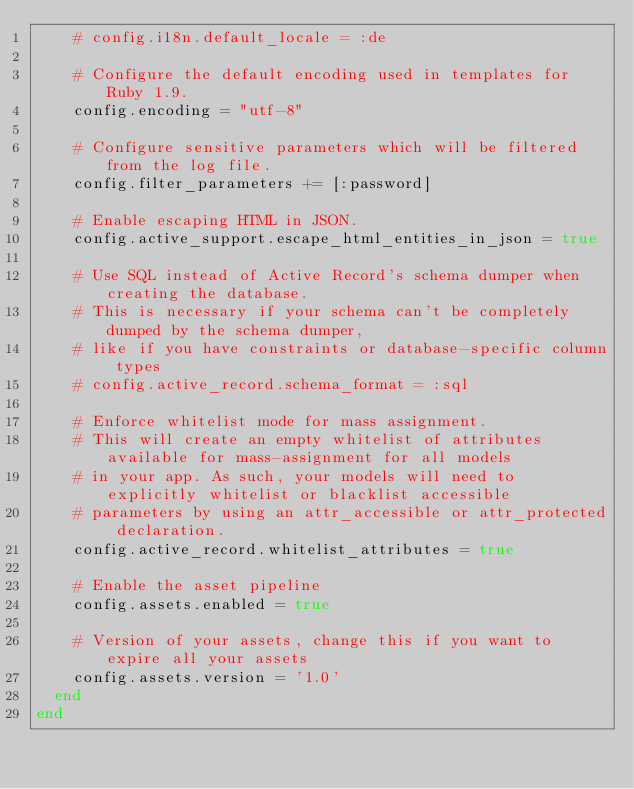Convert code to text. <code><loc_0><loc_0><loc_500><loc_500><_Ruby_>    # config.i18n.default_locale = :de

    # Configure the default encoding used in templates for Ruby 1.9.
    config.encoding = "utf-8"

    # Configure sensitive parameters which will be filtered from the log file.
    config.filter_parameters += [:password]

    # Enable escaping HTML in JSON.
    config.active_support.escape_html_entities_in_json = true

    # Use SQL instead of Active Record's schema dumper when creating the database.
    # This is necessary if your schema can't be completely dumped by the schema dumper,
    # like if you have constraints or database-specific column types
    # config.active_record.schema_format = :sql

    # Enforce whitelist mode for mass assignment.
    # This will create an empty whitelist of attributes available for mass-assignment for all models
    # in your app. As such, your models will need to explicitly whitelist or blacklist accessible
    # parameters by using an attr_accessible or attr_protected declaration.
    config.active_record.whitelist_attributes = true

    # Enable the asset pipeline
    config.assets.enabled = true

    # Version of your assets, change this if you want to expire all your assets
    config.assets.version = '1.0'
  end
end
</code> 